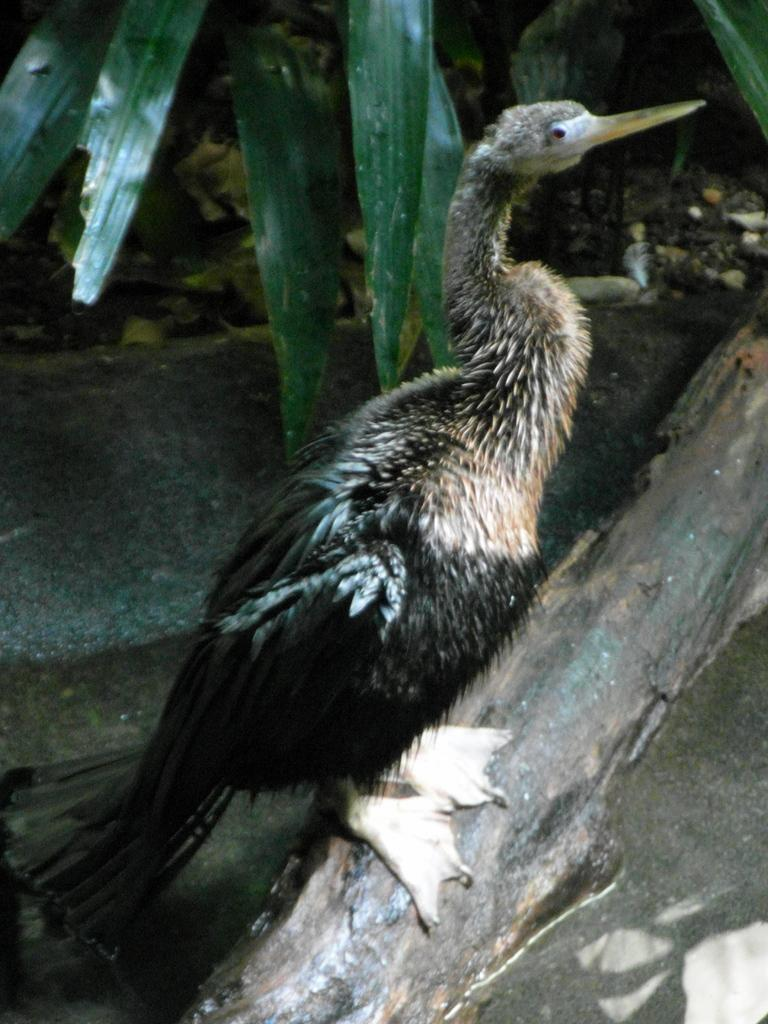What type of animal can be seen in the image? There is a bird in the image. Where is the bird located? The bird is on a wooden log. What natural elements are visible in the image? Water and sand are visible in the image. What other objects can be seen in the image? There are leaves in the image. What time does the clock show in the image? There is no clock present in the image. How does the bird say good-bye to the twig? The bird does not say good-bye to the twig in the image, as it is not an anthropomorphic character. 